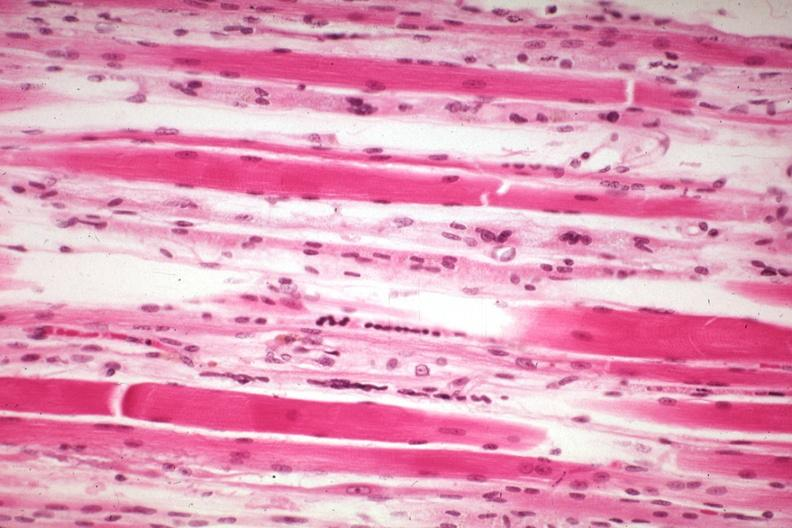s muscle present?
Answer the question using a single word or phrase. Yes 